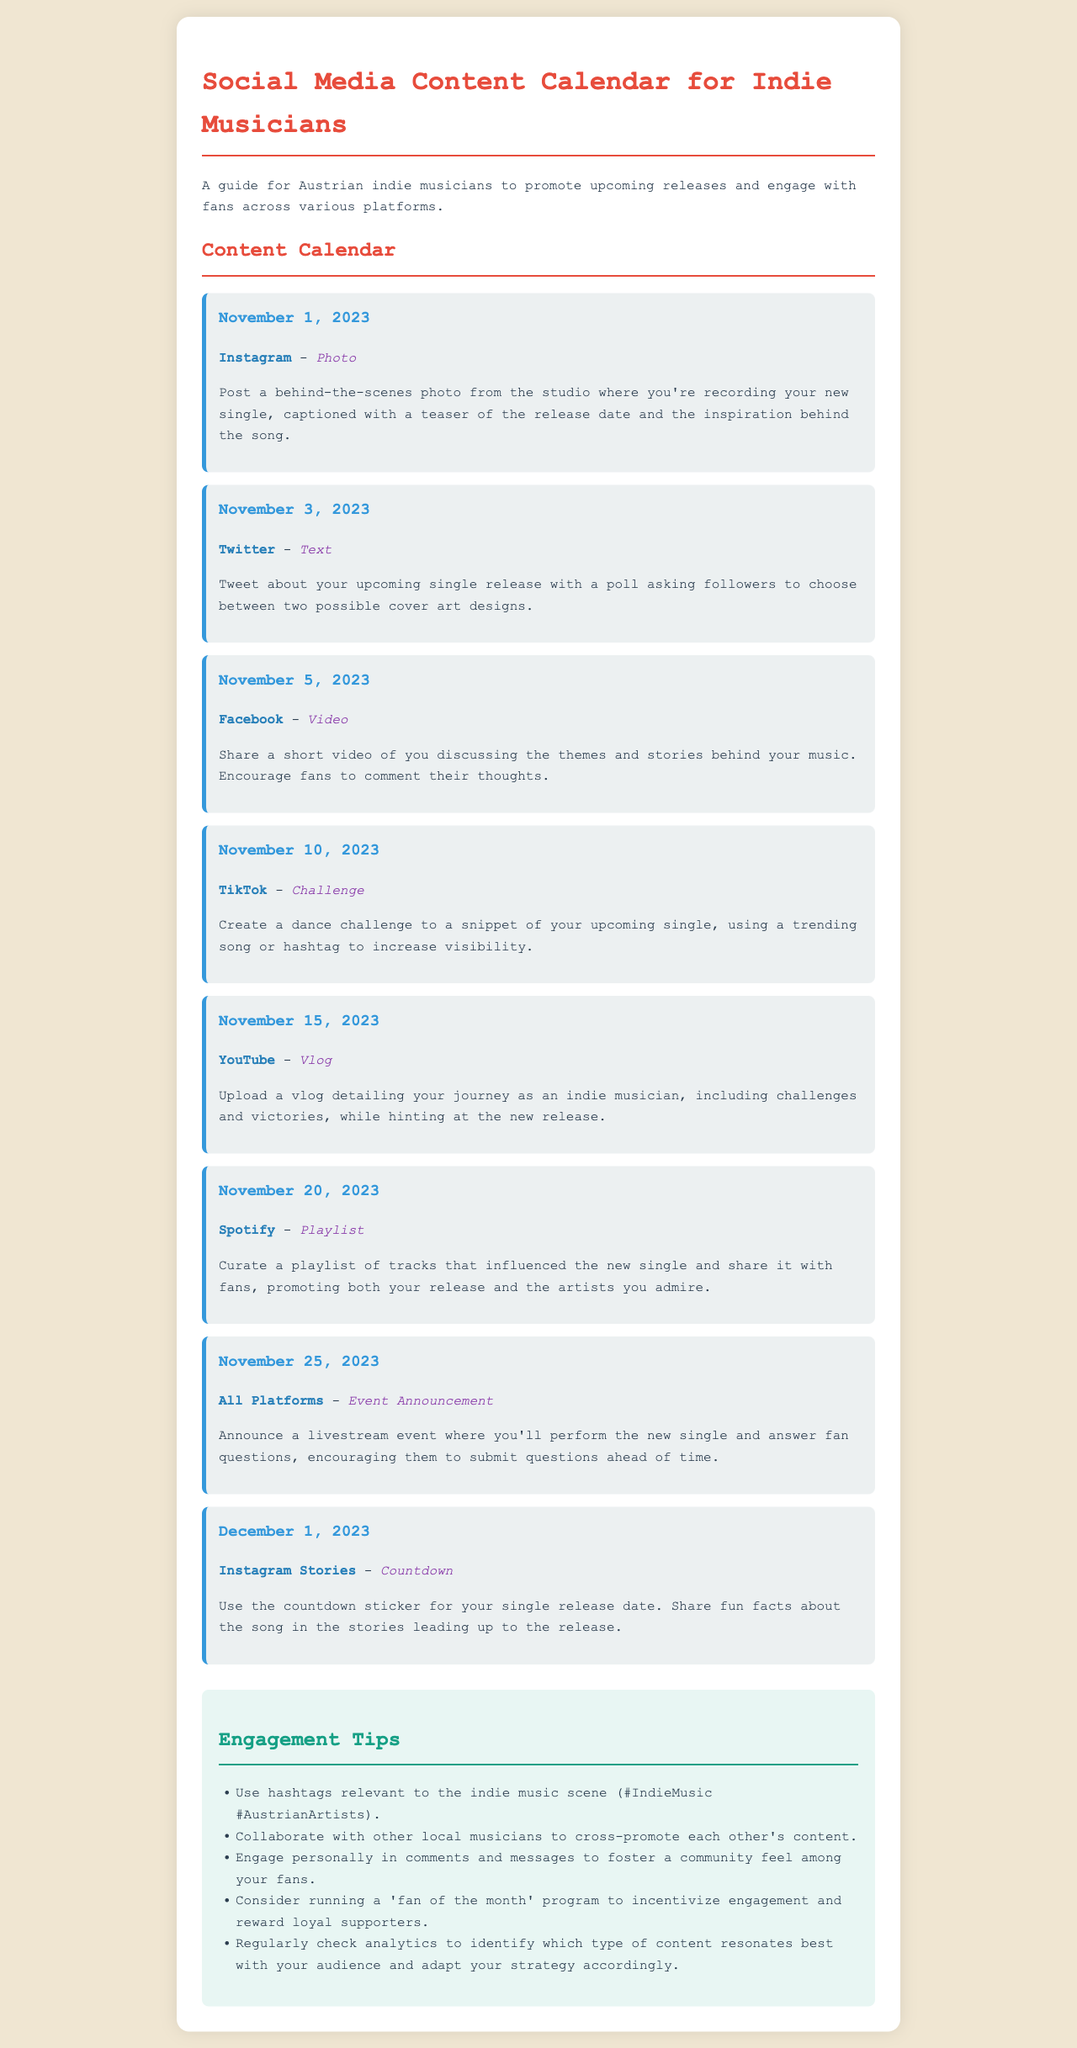What is the release date of the upcoming single? The upcoming single is teased for release on December 1, 2023.
Answer: December 1, 2023 What platform features a dance challenge? The TikTok entry suggests creating a dance challenge to promote the upcoming single.
Answer: TikTok What type of content is suggested for November 5, 2023? The suggested content for November 5 is a video discussing themes and stories behind the music.
Answer: Video How many tips are provided for engagement? The document includes five tips for engagement with fans.
Answer: Five What is the content type of the post scheduled for November 25, 2023? The content type for November 25 is an event announcement for a livestream performance.
Answer: Event Announcement Which platform is suggested for sharing a playlist of influenced tracks? The suggested platform for sharing the playlist is Spotify.
Answer: Spotify What is the purpose of the Instagram Stories on December 1, 2023? The Instagram Stories are for a countdown to the single release while sharing fun facts.
Answer: Countdown What is one of the engagement tips mentioned? One engagement tip includes using relevant hashtags to reach the indie music audience.
Answer: Use hashtags 